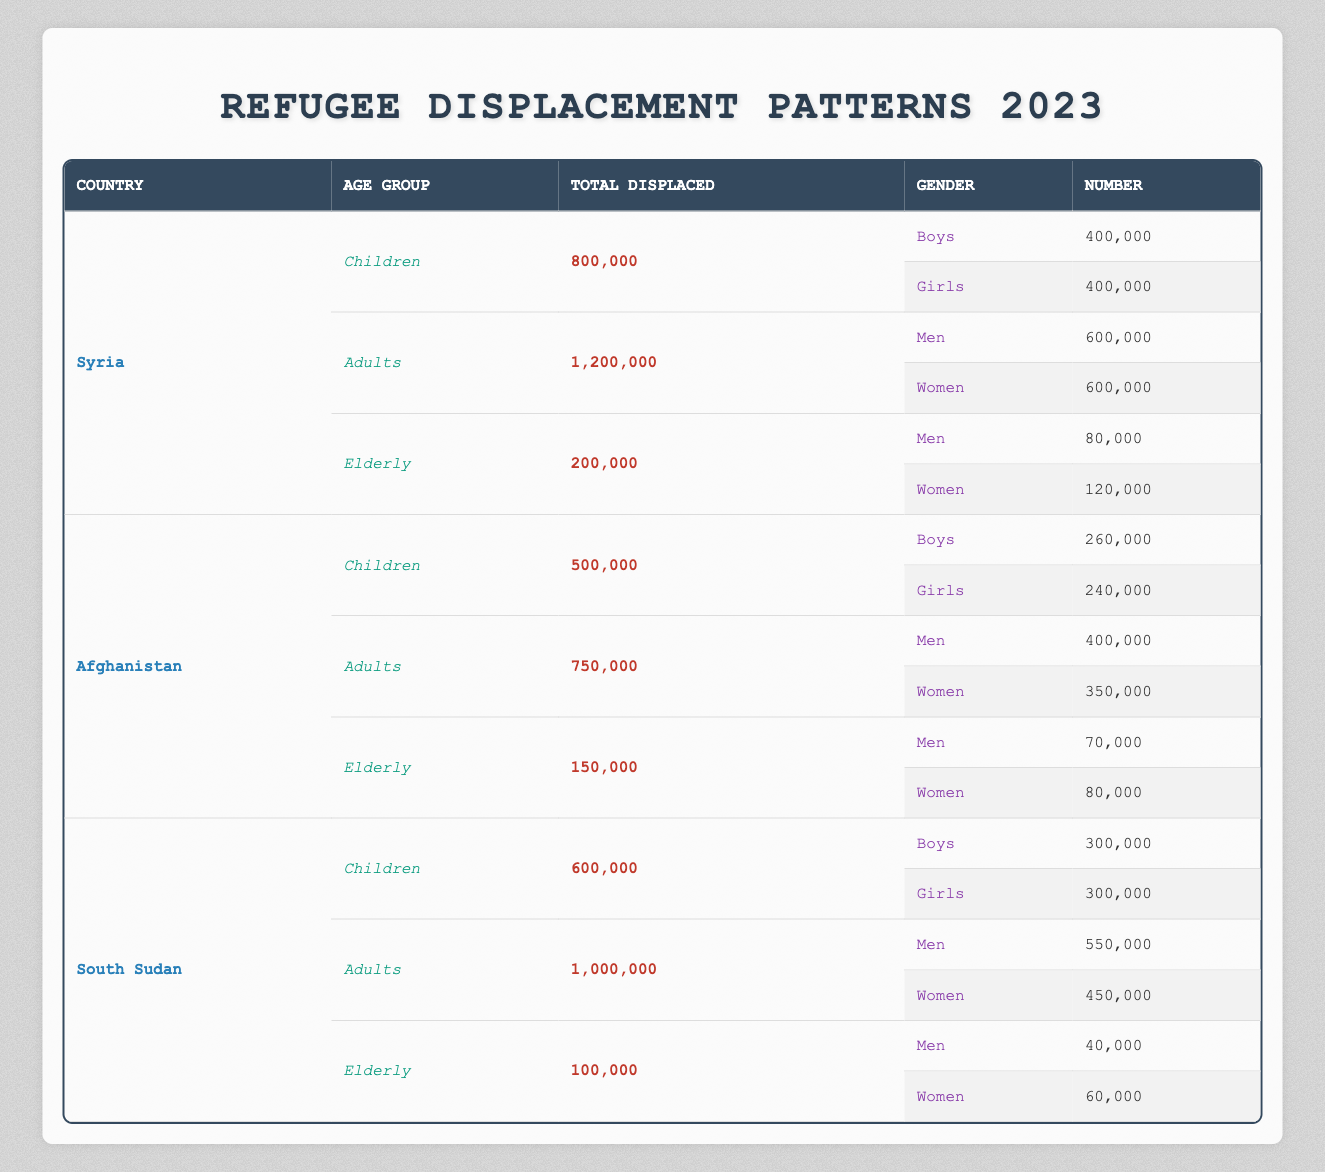What is the total number of displaced children from Syria? The total number of displaced children from Syria can be found directly in the table under Syria's children demographic section, which states a total of 800,000 individuals.
Answer: 800,000 How many displaced men are there in South Sudan? By referring to the South Sudan section in the adults demographic row, we see that 550,000 men are listed under the adults category.
Answer: 550,000 What is the total number of displaced refugees from Afghanistan? To find the total displaced refugees from Afghanistan, we sum the totals of children, adults, and elderly: 500,000 (children) + 750,000 (adults) + 150,000 (elderly) = 1,400,000.
Answer: 1,400,000 Are there more displaced boys or girls in Afghanistan? From the data on Afghan children, there are 260,000 boys and 240,000 girls. Comparing these numbers indicates that there are more boys displaced than girls.
Answer: Yes What percentage of the total displaced in Syria are children? The total displaced in Syria is the sum of all age groups: 800,000 (children) + 1,200,000 (adults) + 200,000 (elderly) = 2,200,000. The percentage of displaced children is calculated as (800,000 / 2,200,000) * 100 = 36.36%.
Answer: 36.36% What is the total number of displaced women across all three countries? We add the number of displaced women from each country: Syria has 600,000, Afghanistan has 350,000, and South Sudan has 450,000. Therefore, the total is 600,000 + 350,000 + 450,000 = 1,400,000.
Answer: 1,400,000 Which country has the highest number of displaced elderly individuals? By reviewing the elderly categories for each country: Syria has 200,000, Afghanistan has 150,000, and South Sudan has 100,000. The highest number is found in Syria with 200,000 elderly displaced.
Answer: Syria How many more men than women were displaced in Afghanistan’s elderly demographic? The elderly demographic in Afghanistan shows 70,000 men and 80,000 women displaced. Therefore, the difference is calculated as 70,000 - 80,000, which results in -10,000, meaning there are 10,000 more women than men.
Answer: 10,000 more women What is the total displaced population of children and adults combined in South Sudan? We look at the totals for children (600,000) and adults (1,000,000) in South Sudan. Adding these together gives 600,000 + 1,000,000 = 1,600,000.
Answer: 1,600,000 